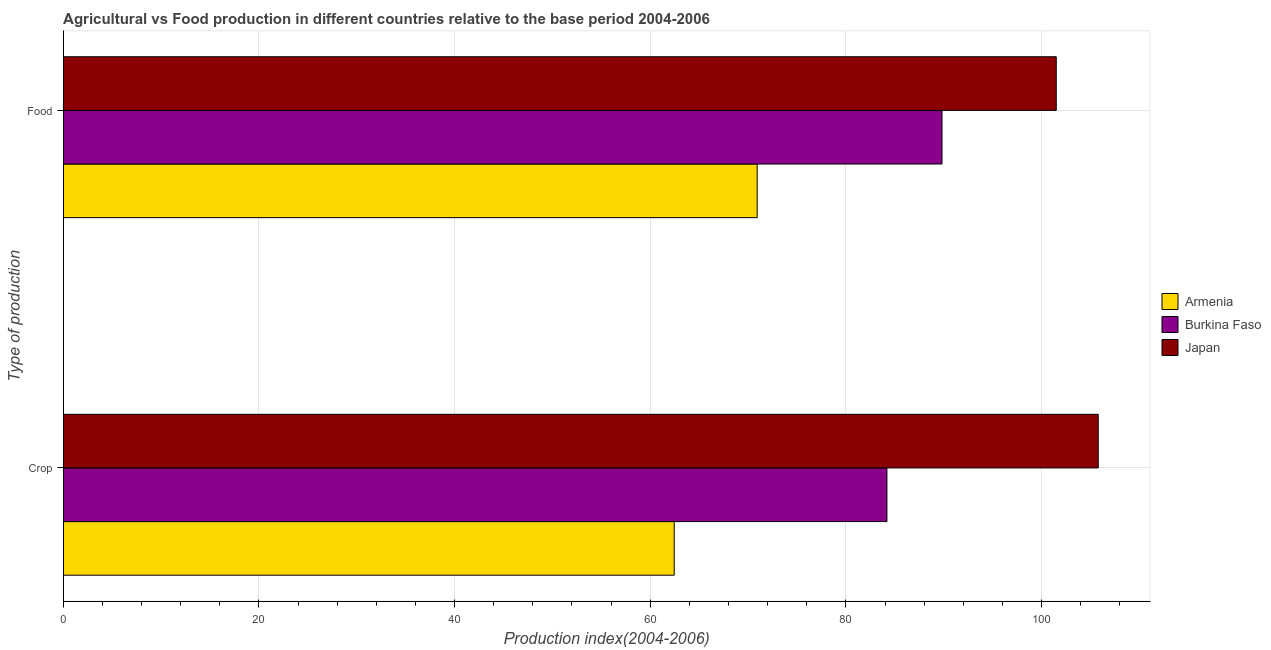How many bars are there on the 1st tick from the top?
Keep it short and to the point. 3. How many bars are there on the 1st tick from the bottom?
Offer a very short reply. 3. What is the label of the 1st group of bars from the top?
Provide a short and direct response. Food. What is the food production index in Burkina Faso?
Your answer should be very brief. 89.82. Across all countries, what is the maximum crop production index?
Ensure brevity in your answer.  105.79. Across all countries, what is the minimum crop production index?
Give a very brief answer. 62.45. In which country was the food production index minimum?
Ensure brevity in your answer.  Armenia. What is the total food production index in the graph?
Your response must be concise. 262.25. What is the difference between the crop production index in Japan and that in Burkina Faso?
Keep it short and to the point. 21.6. What is the difference between the food production index in Armenia and the crop production index in Japan?
Your answer should be compact. -34.86. What is the average food production index per country?
Ensure brevity in your answer.  87.42. What is the difference between the crop production index and food production index in Armenia?
Keep it short and to the point. -8.48. What is the ratio of the crop production index in Armenia to that in Japan?
Ensure brevity in your answer.  0.59. In how many countries, is the crop production index greater than the average crop production index taken over all countries?
Your answer should be very brief. 2. What does the 1st bar from the top in Crop represents?
Make the answer very short. Japan. What does the 1st bar from the bottom in Crop represents?
Offer a very short reply. Armenia. How many bars are there?
Your response must be concise. 6. Are all the bars in the graph horizontal?
Your answer should be very brief. Yes. Does the graph contain grids?
Keep it short and to the point. Yes. How are the legend labels stacked?
Your response must be concise. Vertical. What is the title of the graph?
Make the answer very short. Agricultural vs Food production in different countries relative to the base period 2004-2006. Does "Macedonia" appear as one of the legend labels in the graph?
Keep it short and to the point. No. What is the label or title of the X-axis?
Keep it short and to the point. Production index(2004-2006). What is the label or title of the Y-axis?
Offer a terse response. Type of production. What is the Production index(2004-2006) in Armenia in Crop?
Your answer should be very brief. 62.45. What is the Production index(2004-2006) of Burkina Faso in Crop?
Your response must be concise. 84.19. What is the Production index(2004-2006) of Japan in Crop?
Provide a short and direct response. 105.79. What is the Production index(2004-2006) of Armenia in Food?
Your response must be concise. 70.93. What is the Production index(2004-2006) in Burkina Faso in Food?
Offer a terse response. 89.82. What is the Production index(2004-2006) in Japan in Food?
Offer a very short reply. 101.5. Across all Type of production, what is the maximum Production index(2004-2006) of Armenia?
Ensure brevity in your answer.  70.93. Across all Type of production, what is the maximum Production index(2004-2006) of Burkina Faso?
Your answer should be compact. 89.82. Across all Type of production, what is the maximum Production index(2004-2006) in Japan?
Make the answer very short. 105.79. Across all Type of production, what is the minimum Production index(2004-2006) in Armenia?
Keep it short and to the point. 62.45. Across all Type of production, what is the minimum Production index(2004-2006) of Burkina Faso?
Provide a short and direct response. 84.19. Across all Type of production, what is the minimum Production index(2004-2006) in Japan?
Provide a succinct answer. 101.5. What is the total Production index(2004-2006) in Armenia in the graph?
Provide a short and direct response. 133.38. What is the total Production index(2004-2006) of Burkina Faso in the graph?
Provide a succinct answer. 174.01. What is the total Production index(2004-2006) of Japan in the graph?
Give a very brief answer. 207.29. What is the difference between the Production index(2004-2006) in Armenia in Crop and that in Food?
Provide a succinct answer. -8.48. What is the difference between the Production index(2004-2006) in Burkina Faso in Crop and that in Food?
Provide a short and direct response. -5.63. What is the difference between the Production index(2004-2006) in Japan in Crop and that in Food?
Give a very brief answer. 4.29. What is the difference between the Production index(2004-2006) in Armenia in Crop and the Production index(2004-2006) in Burkina Faso in Food?
Keep it short and to the point. -27.37. What is the difference between the Production index(2004-2006) of Armenia in Crop and the Production index(2004-2006) of Japan in Food?
Give a very brief answer. -39.05. What is the difference between the Production index(2004-2006) of Burkina Faso in Crop and the Production index(2004-2006) of Japan in Food?
Provide a succinct answer. -17.31. What is the average Production index(2004-2006) in Armenia per Type of production?
Ensure brevity in your answer.  66.69. What is the average Production index(2004-2006) of Burkina Faso per Type of production?
Ensure brevity in your answer.  87. What is the average Production index(2004-2006) in Japan per Type of production?
Provide a short and direct response. 103.64. What is the difference between the Production index(2004-2006) in Armenia and Production index(2004-2006) in Burkina Faso in Crop?
Your response must be concise. -21.74. What is the difference between the Production index(2004-2006) of Armenia and Production index(2004-2006) of Japan in Crop?
Provide a short and direct response. -43.34. What is the difference between the Production index(2004-2006) in Burkina Faso and Production index(2004-2006) in Japan in Crop?
Give a very brief answer. -21.6. What is the difference between the Production index(2004-2006) of Armenia and Production index(2004-2006) of Burkina Faso in Food?
Offer a very short reply. -18.89. What is the difference between the Production index(2004-2006) of Armenia and Production index(2004-2006) of Japan in Food?
Keep it short and to the point. -30.57. What is the difference between the Production index(2004-2006) in Burkina Faso and Production index(2004-2006) in Japan in Food?
Offer a terse response. -11.68. What is the ratio of the Production index(2004-2006) in Armenia in Crop to that in Food?
Give a very brief answer. 0.88. What is the ratio of the Production index(2004-2006) in Burkina Faso in Crop to that in Food?
Provide a short and direct response. 0.94. What is the ratio of the Production index(2004-2006) of Japan in Crop to that in Food?
Give a very brief answer. 1.04. What is the difference between the highest and the second highest Production index(2004-2006) in Armenia?
Give a very brief answer. 8.48. What is the difference between the highest and the second highest Production index(2004-2006) in Burkina Faso?
Offer a terse response. 5.63. What is the difference between the highest and the second highest Production index(2004-2006) in Japan?
Offer a very short reply. 4.29. What is the difference between the highest and the lowest Production index(2004-2006) in Armenia?
Offer a very short reply. 8.48. What is the difference between the highest and the lowest Production index(2004-2006) in Burkina Faso?
Offer a terse response. 5.63. What is the difference between the highest and the lowest Production index(2004-2006) in Japan?
Ensure brevity in your answer.  4.29. 